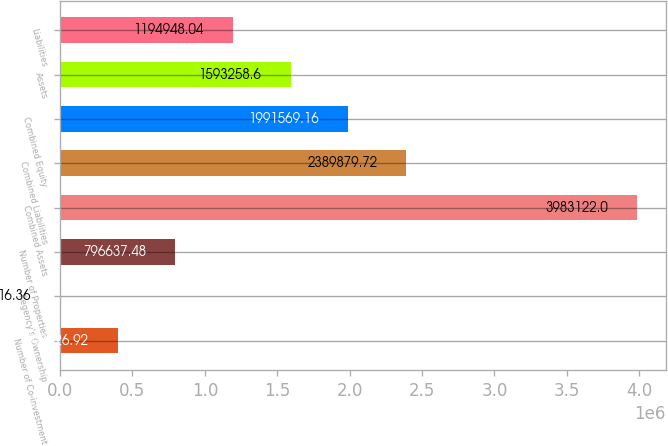Convert chart. <chart><loc_0><loc_0><loc_500><loc_500><bar_chart><fcel>Number of Co-investment<fcel>Regency's Ownership<fcel>Number of Properties<fcel>Combined Assets<fcel>Combined Liabilities<fcel>Combined Equity<fcel>Assets<fcel>Liabilities<nl><fcel>398327<fcel>16.36<fcel>796637<fcel>3.98312e+06<fcel>2.38988e+06<fcel>1.99157e+06<fcel>1.59326e+06<fcel>1.19495e+06<nl></chart> 